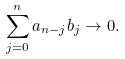Convert formula to latex. <formula><loc_0><loc_0><loc_500><loc_500>\sum _ { j = 0 } ^ { n } a _ { n - j } b _ { j } \to 0 .</formula> 